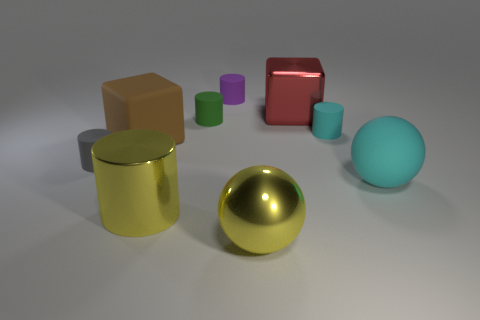Subtract all big shiny cylinders. How many cylinders are left? 4 Subtract all balls. How many objects are left? 7 Subtract 1 cylinders. How many cylinders are left? 4 Subtract all tiny brown metal cubes. Subtract all gray rubber things. How many objects are left? 8 Add 7 green objects. How many green objects are left? 8 Add 5 red cubes. How many red cubes exist? 6 Add 1 tiny yellow metal cylinders. How many objects exist? 10 Subtract all cyan balls. How many balls are left? 1 Subtract 0 red spheres. How many objects are left? 9 Subtract all green cubes. Subtract all brown balls. How many cubes are left? 2 